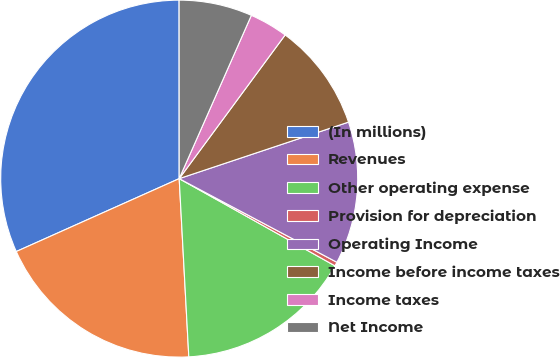Convert chart to OTSL. <chart><loc_0><loc_0><loc_500><loc_500><pie_chart><fcel>(In millions)<fcel>Revenues<fcel>Other operating expense<fcel>Provision for depreciation<fcel>Operating Income<fcel>Income before income taxes<fcel>Income taxes<fcel>Net Income<nl><fcel>31.69%<fcel>19.16%<fcel>16.02%<fcel>0.36%<fcel>12.89%<fcel>9.76%<fcel>3.49%<fcel>6.63%<nl></chart> 